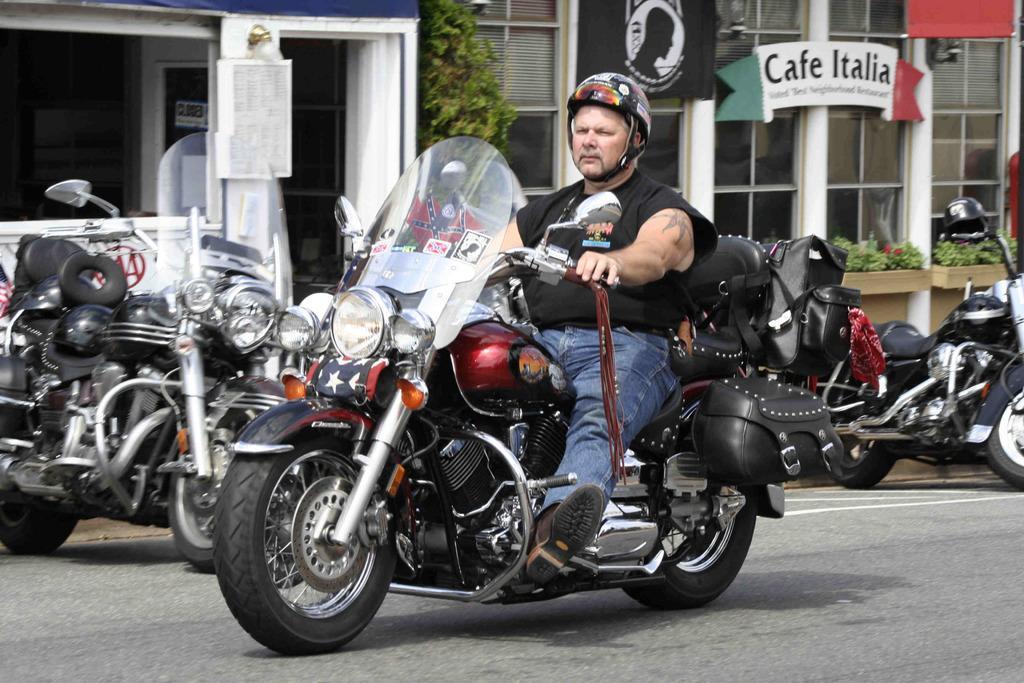How would you summarize this image in a sentence or two? In this image, I can see a person riding a bike, who is wearing a helmet on his head on the road. In the background, I can see some buildings where hoarding is there and Cafe Italia board is there. On the middle of the background, I can see some house plants. In the middle of the background, I can see a tree. In the left top of the background, I can see a door of the house which is opened. On the road there are number of bikes parked. 